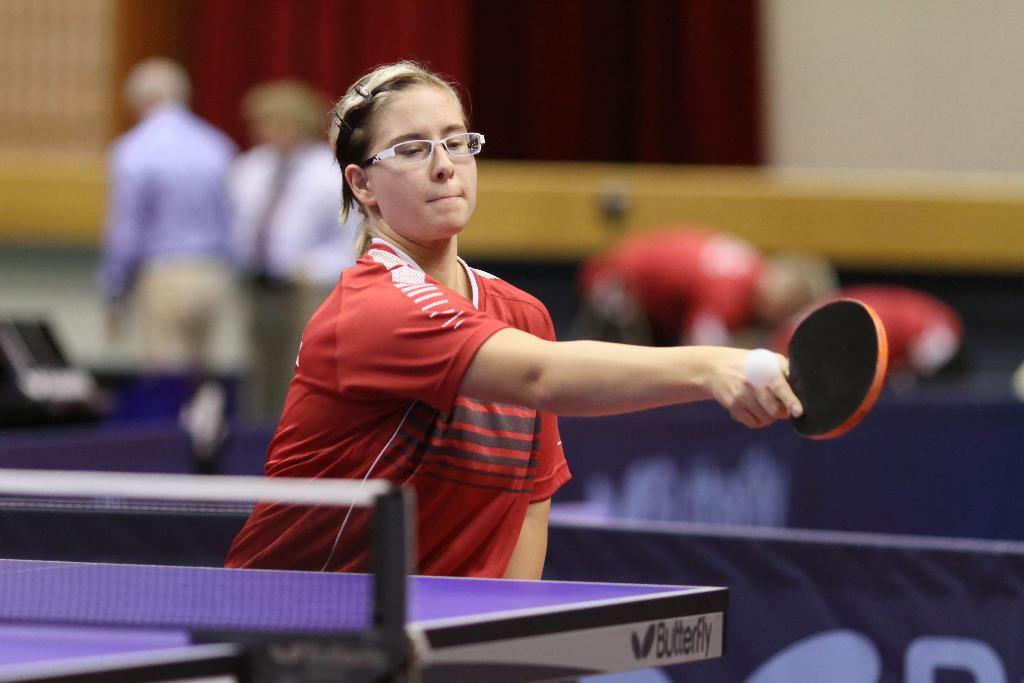How would you summarize this image in a sentence or two? In this picture a girl playing a table tennis, i could see in her right hand she is holding a bat and hitting a ball she is wearing a red colored t shirt and in the left corner there is a table tennis table. In the back ground i could see people wearing red t shirt and to the left background i could see wearing a formals. 